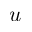Convert formula to latex. <formula><loc_0><loc_0><loc_500><loc_500>u</formula> 